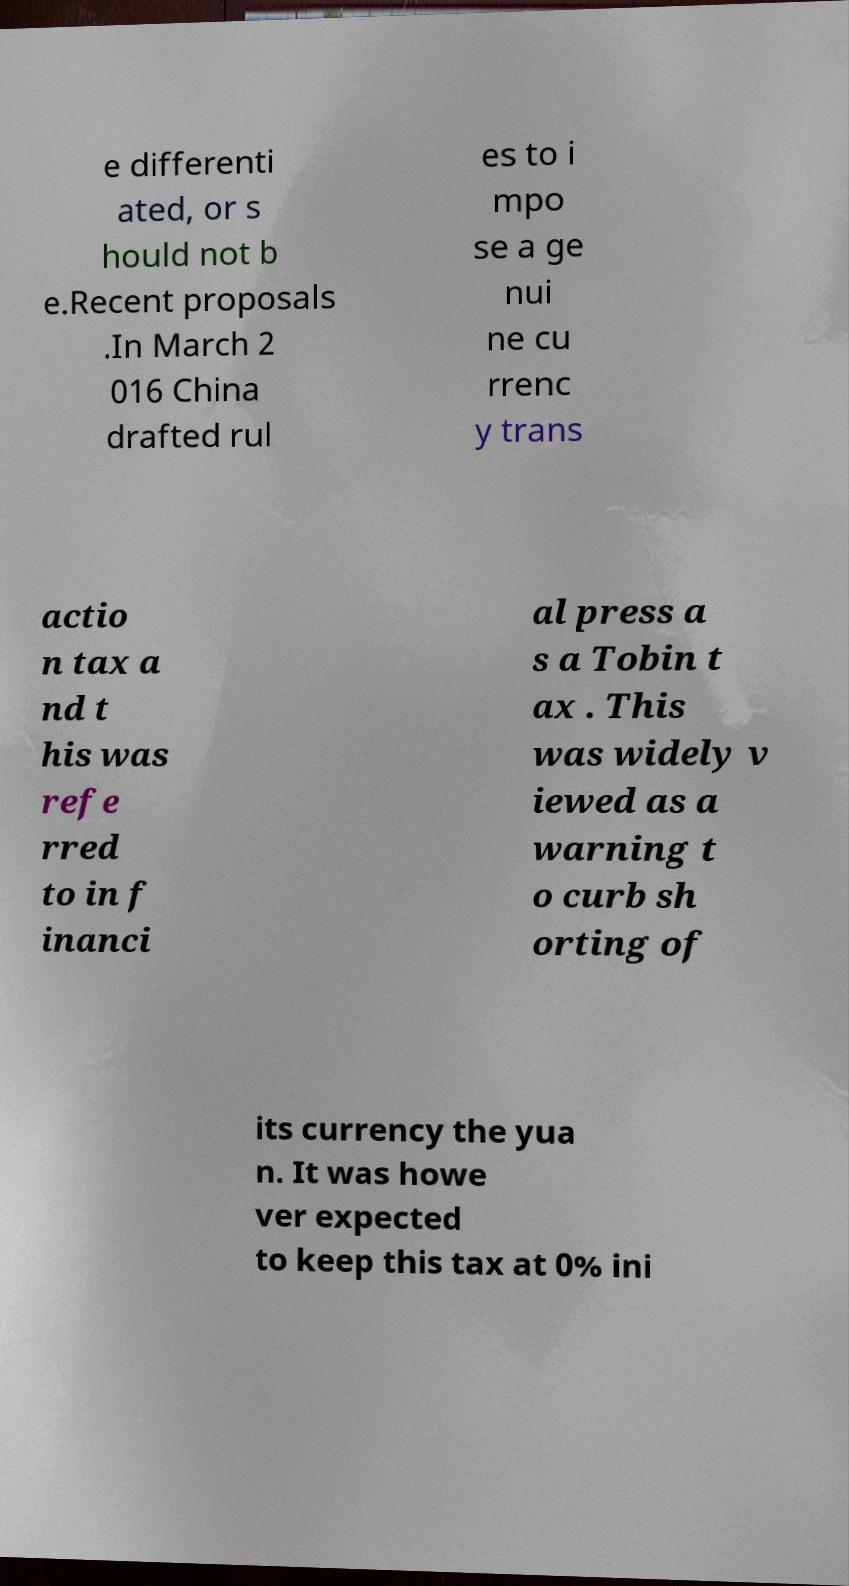There's text embedded in this image that I need extracted. Can you transcribe it verbatim? e differenti ated, or s hould not b e.Recent proposals .In March 2 016 China drafted rul es to i mpo se a ge nui ne cu rrenc y trans actio n tax a nd t his was refe rred to in f inanci al press a s a Tobin t ax . This was widely v iewed as a warning t o curb sh orting of its currency the yua n. It was howe ver expected to keep this tax at 0% ini 